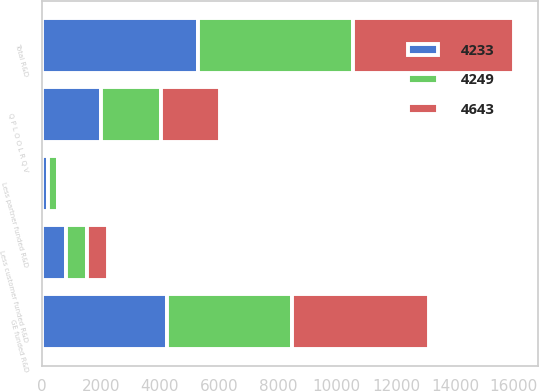Convert chart. <chart><loc_0><loc_0><loc_500><loc_500><stacked_bar_chart><ecel><fcel>Q P L O O L R Q V<fcel>Total R&D<fcel>Less customer funded R&D<fcel>Less partner funded R&D<fcel>GE funded R&D<nl><fcel>4233<fcel>2015<fcel>5278<fcel>803<fcel>226<fcel>4249<nl><fcel>4249<fcel>2014<fcel>5273<fcel>721<fcel>319<fcel>4233<nl><fcel>4643<fcel>2013<fcel>5461<fcel>711<fcel>107<fcel>4643<nl></chart> 